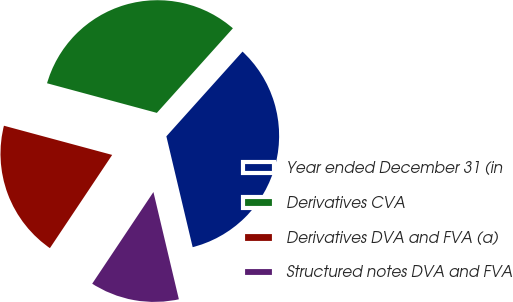Convert chart to OTSL. <chart><loc_0><loc_0><loc_500><loc_500><pie_chart><fcel>Year ended December 31 (in<fcel>Derivatives CVA<fcel>Derivatives DVA and FVA (a)<fcel>Structured notes DVA and FVA<nl><fcel>34.64%<fcel>32.46%<fcel>19.82%<fcel>13.08%<nl></chart> 